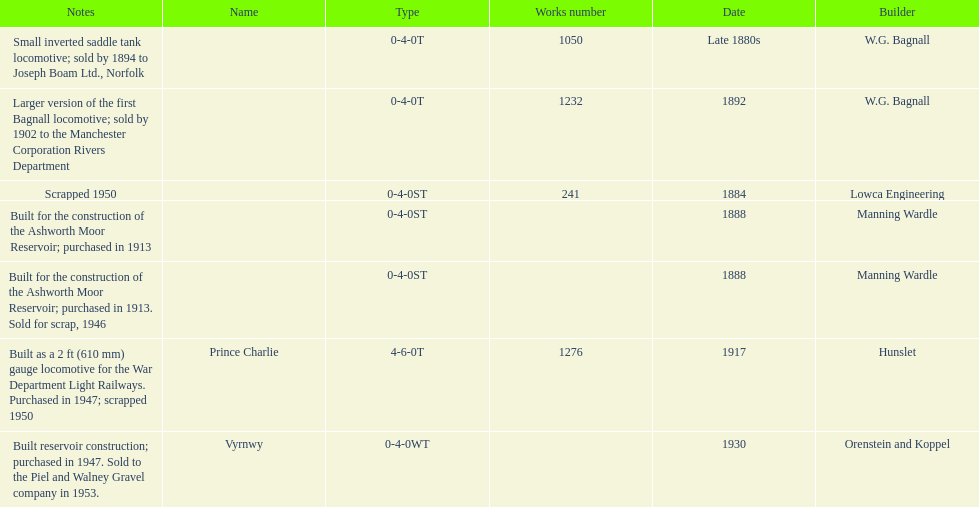How many trains were discarded? 3. 